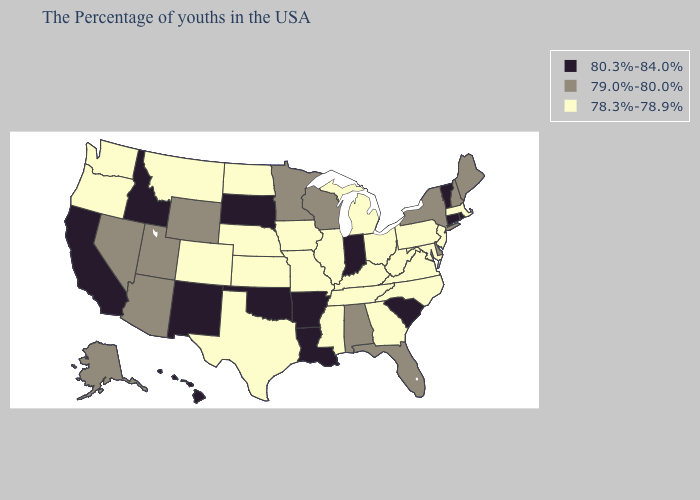Does Arkansas have the lowest value in the South?
Give a very brief answer. No. Name the states that have a value in the range 80.3%-84.0%?
Be succinct. Rhode Island, Vermont, Connecticut, South Carolina, Indiana, Louisiana, Arkansas, Oklahoma, South Dakota, New Mexico, Idaho, California, Hawaii. Does Hawaii have the same value as South Carolina?
Write a very short answer. Yes. Among the states that border Utah , does Idaho have the highest value?
Write a very short answer. Yes. What is the value of Rhode Island?
Answer briefly. 80.3%-84.0%. Is the legend a continuous bar?
Write a very short answer. No. Does Washington have the highest value in the West?
Keep it brief. No. Which states hav the highest value in the West?
Quick response, please. New Mexico, Idaho, California, Hawaii. What is the highest value in the USA?
Answer briefly. 80.3%-84.0%. Among the states that border Missouri , does Kansas have the highest value?
Answer briefly. No. Among the states that border Michigan , does Ohio have the lowest value?
Concise answer only. Yes. Name the states that have a value in the range 79.0%-80.0%?
Keep it brief. Maine, New Hampshire, New York, Delaware, Florida, Alabama, Wisconsin, Minnesota, Wyoming, Utah, Arizona, Nevada, Alaska. Which states hav the highest value in the MidWest?
Keep it brief. Indiana, South Dakota. Which states have the lowest value in the South?
Be succinct. Maryland, Virginia, North Carolina, West Virginia, Georgia, Kentucky, Tennessee, Mississippi, Texas. 